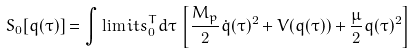<formula> <loc_0><loc_0><loc_500><loc_500>S _ { 0 } [ q ( \tau ) ] = \int \lim i t s _ { 0 } ^ { T } d \tau \, \left [ \frac { M _ { p } } { 2 } \dot { q } ( \tau ) ^ { 2 } + V ( q ( \tau ) ) + \frac { \mu } { 2 } q ( \tau ) ^ { 2 } \right ]</formula> 